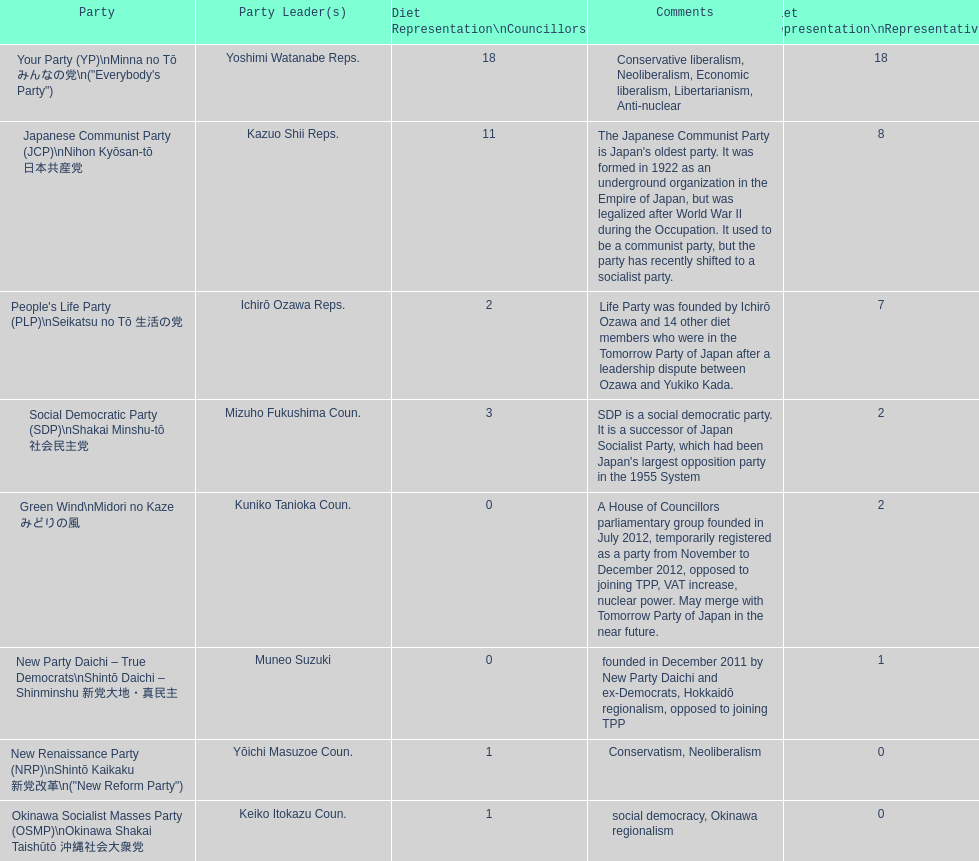How many of these parties currently have no councillors? 2. 